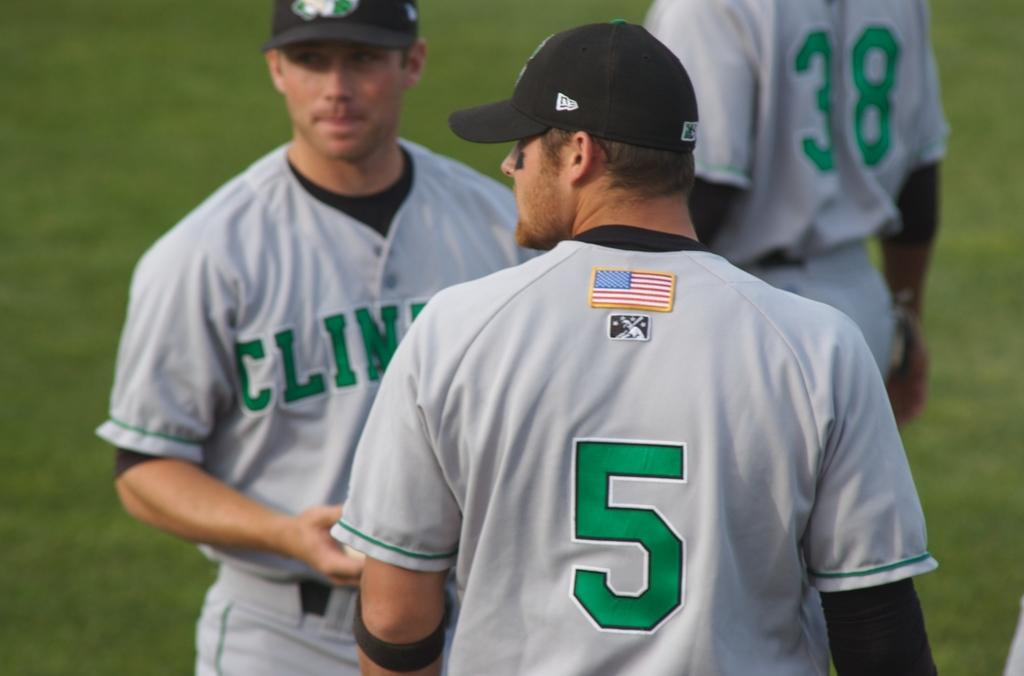<image>
Summarize the visual content of the image. The player that wears number 5 is a player on a baseball team. 